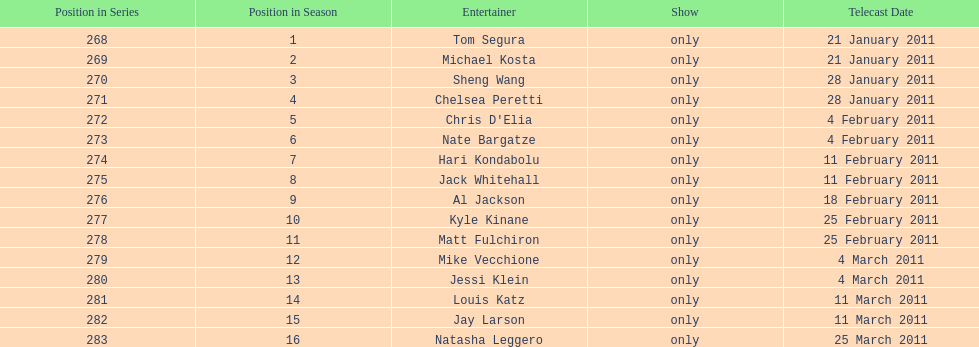How many weeks did season 15 of comedy central presents span? 9. 